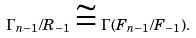Convert formula to latex. <formula><loc_0><loc_0><loc_500><loc_500>\Gamma _ { n - 1 } / R _ { - 1 } \cong \Gamma ( F _ { n - 1 } / F _ { - 1 } ) .</formula> 